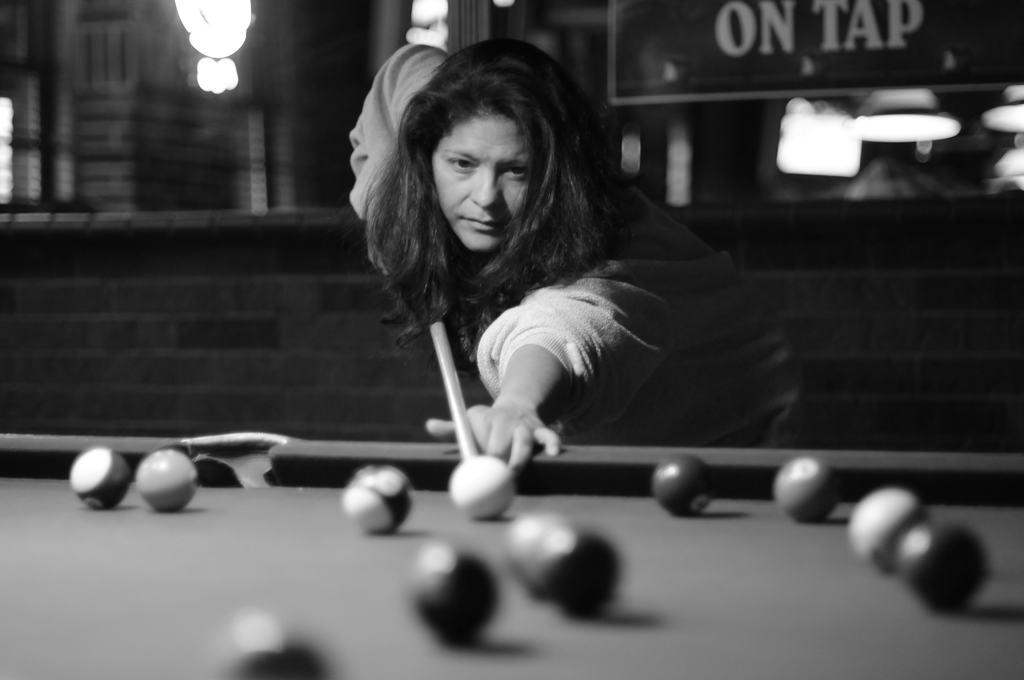Who is the main subject in the image? There is a woman in the image. What is the woman doing in the image? The woman is playing billiards. What type of fork is the woman using to play billiards in the image? There is no fork present in the image, and the woman is not using any utensils to play billiards. 